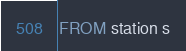Convert code to text. <code><loc_0><loc_0><loc_500><loc_500><_SQL_>FROM station s
</code> 